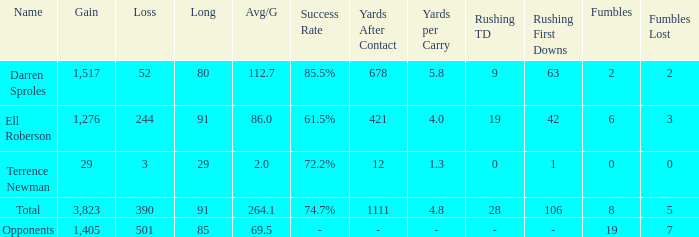What's the sum of all average yards gained when the gained yards is under 1,276 and lost more than 3 yards? None. 